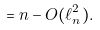Convert formula to latex. <formula><loc_0><loc_0><loc_500><loc_500>= n - O ( \ell _ { n } ^ { 2 } ) .</formula> 